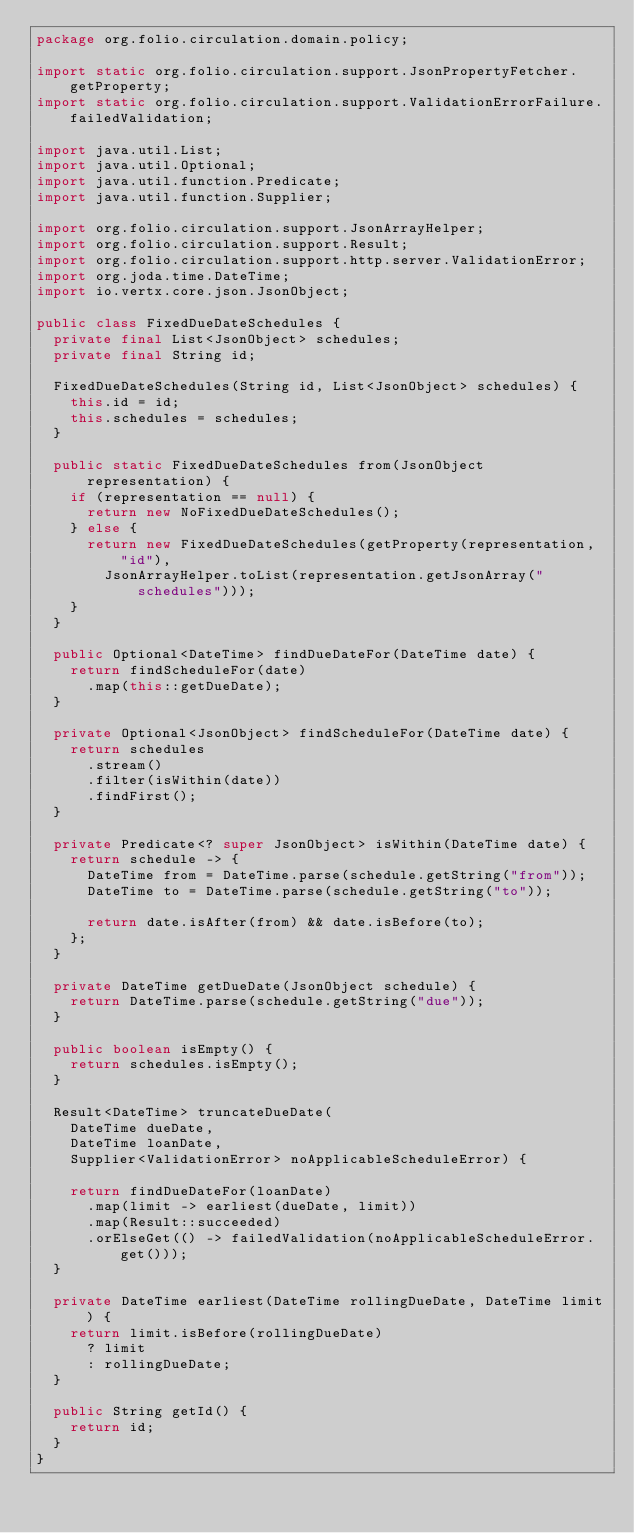<code> <loc_0><loc_0><loc_500><loc_500><_Java_>package org.folio.circulation.domain.policy;

import static org.folio.circulation.support.JsonPropertyFetcher.getProperty;
import static org.folio.circulation.support.ValidationErrorFailure.failedValidation;

import java.util.List;
import java.util.Optional;
import java.util.function.Predicate;
import java.util.function.Supplier;

import org.folio.circulation.support.JsonArrayHelper;
import org.folio.circulation.support.Result;
import org.folio.circulation.support.http.server.ValidationError;
import org.joda.time.DateTime;
import io.vertx.core.json.JsonObject;

public class FixedDueDateSchedules {
  private final List<JsonObject> schedules;
  private final String id;

  FixedDueDateSchedules(String id, List<JsonObject> schedules) {
    this.id = id;
    this.schedules = schedules;
  }

  public static FixedDueDateSchedules from(JsonObject representation) {
    if (representation == null) {
      return new NoFixedDueDateSchedules();
    } else {
      return new FixedDueDateSchedules(getProperty(representation, "id"),
        JsonArrayHelper.toList(representation.getJsonArray("schedules")));
    }
  }

  public Optional<DateTime> findDueDateFor(DateTime date) {
    return findScheduleFor(date)
      .map(this::getDueDate);
  }

  private Optional<JsonObject> findScheduleFor(DateTime date) {
    return schedules
      .stream()
      .filter(isWithin(date))
      .findFirst();
  }

  private Predicate<? super JsonObject> isWithin(DateTime date) {
    return schedule -> {
      DateTime from = DateTime.parse(schedule.getString("from"));
      DateTime to = DateTime.parse(schedule.getString("to"));

      return date.isAfter(from) && date.isBefore(to);
    };
  }

  private DateTime getDueDate(JsonObject schedule) {
    return DateTime.parse(schedule.getString("due"));
  }

  public boolean isEmpty() {
    return schedules.isEmpty();
  }

  Result<DateTime> truncateDueDate(
    DateTime dueDate,
    DateTime loanDate,
    Supplier<ValidationError> noApplicableScheduleError) {

    return findDueDateFor(loanDate)
      .map(limit -> earliest(dueDate, limit))
      .map(Result::succeeded)
      .orElseGet(() -> failedValidation(noApplicableScheduleError.get()));
  }

  private DateTime earliest(DateTime rollingDueDate, DateTime limit) {
    return limit.isBefore(rollingDueDate)
      ? limit
      : rollingDueDate;
  }

  public String getId() {
    return id;
  }
}
</code> 